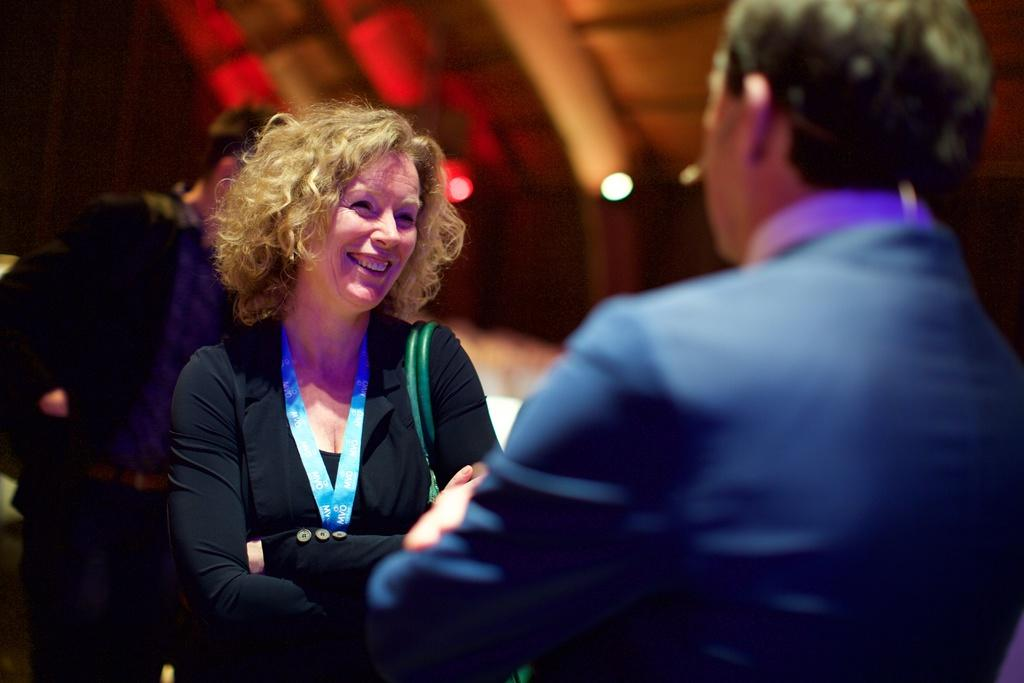What is the visual quality of the foreground in the image? The foreground of the image is blurred. Who is the main subject in the middle of the image? There is a woman in the middle of the image. Can you describe the person on the left side of the image? There is a person on the left side of the image. What is the visual quality of the background in the image? The background of the image is blurred. What shape is the pump taking during the discussion in the image? There is no pump or discussion present in the image. 